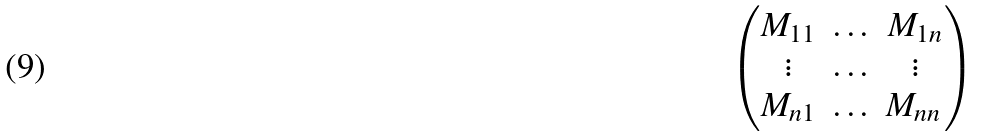Convert formula to latex. <formula><loc_0><loc_0><loc_500><loc_500>\begin{pmatrix} M _ { 1 1 } & \hdots & M _ { 1 n } \\ \vdots & \hdots & \vdots \\ M _ { n 1 } & \hdots & M _ { n n } \, \end{pmatrix}</formula> 